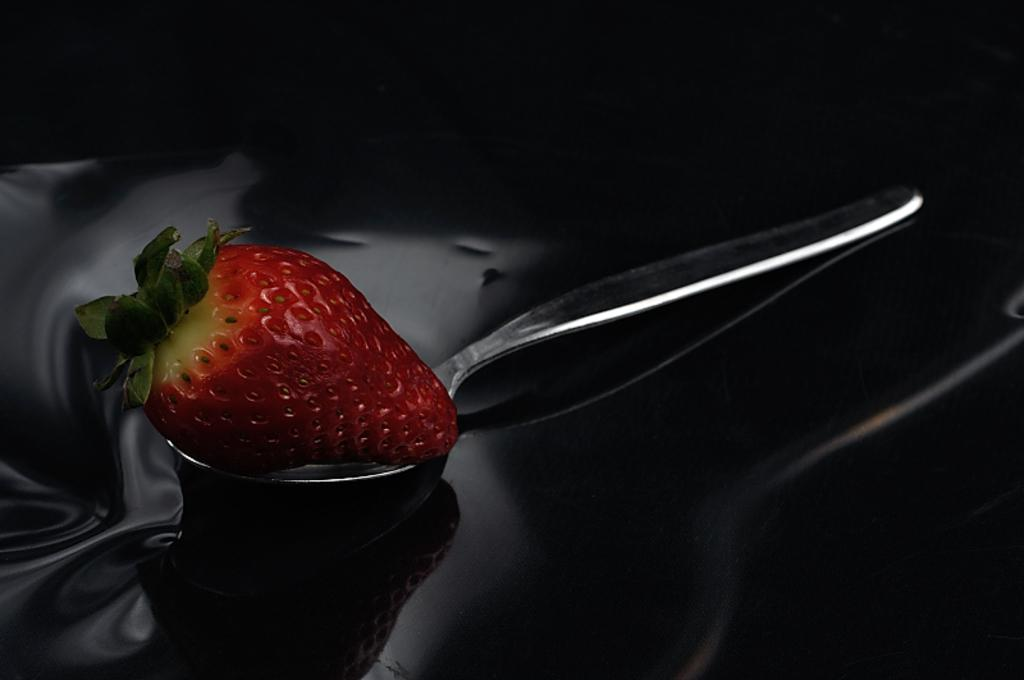What is the color of the strawberry in the image? The strawberry in the image is red. What can be seen on the top of the strawberry? The strawberry has leaves on the top. What is the strawberry placed on in the image? The strawberry is on a steel spoon. What is the color of the object that the steel spoon is on? The steel spoon is on a black color object. What is the color of the background in the image? The background of the image is black in color. How does the kite change the color of the strawberry in the image? There is no kite present in the image, and therefore it cannot change the color of the strawberry. 